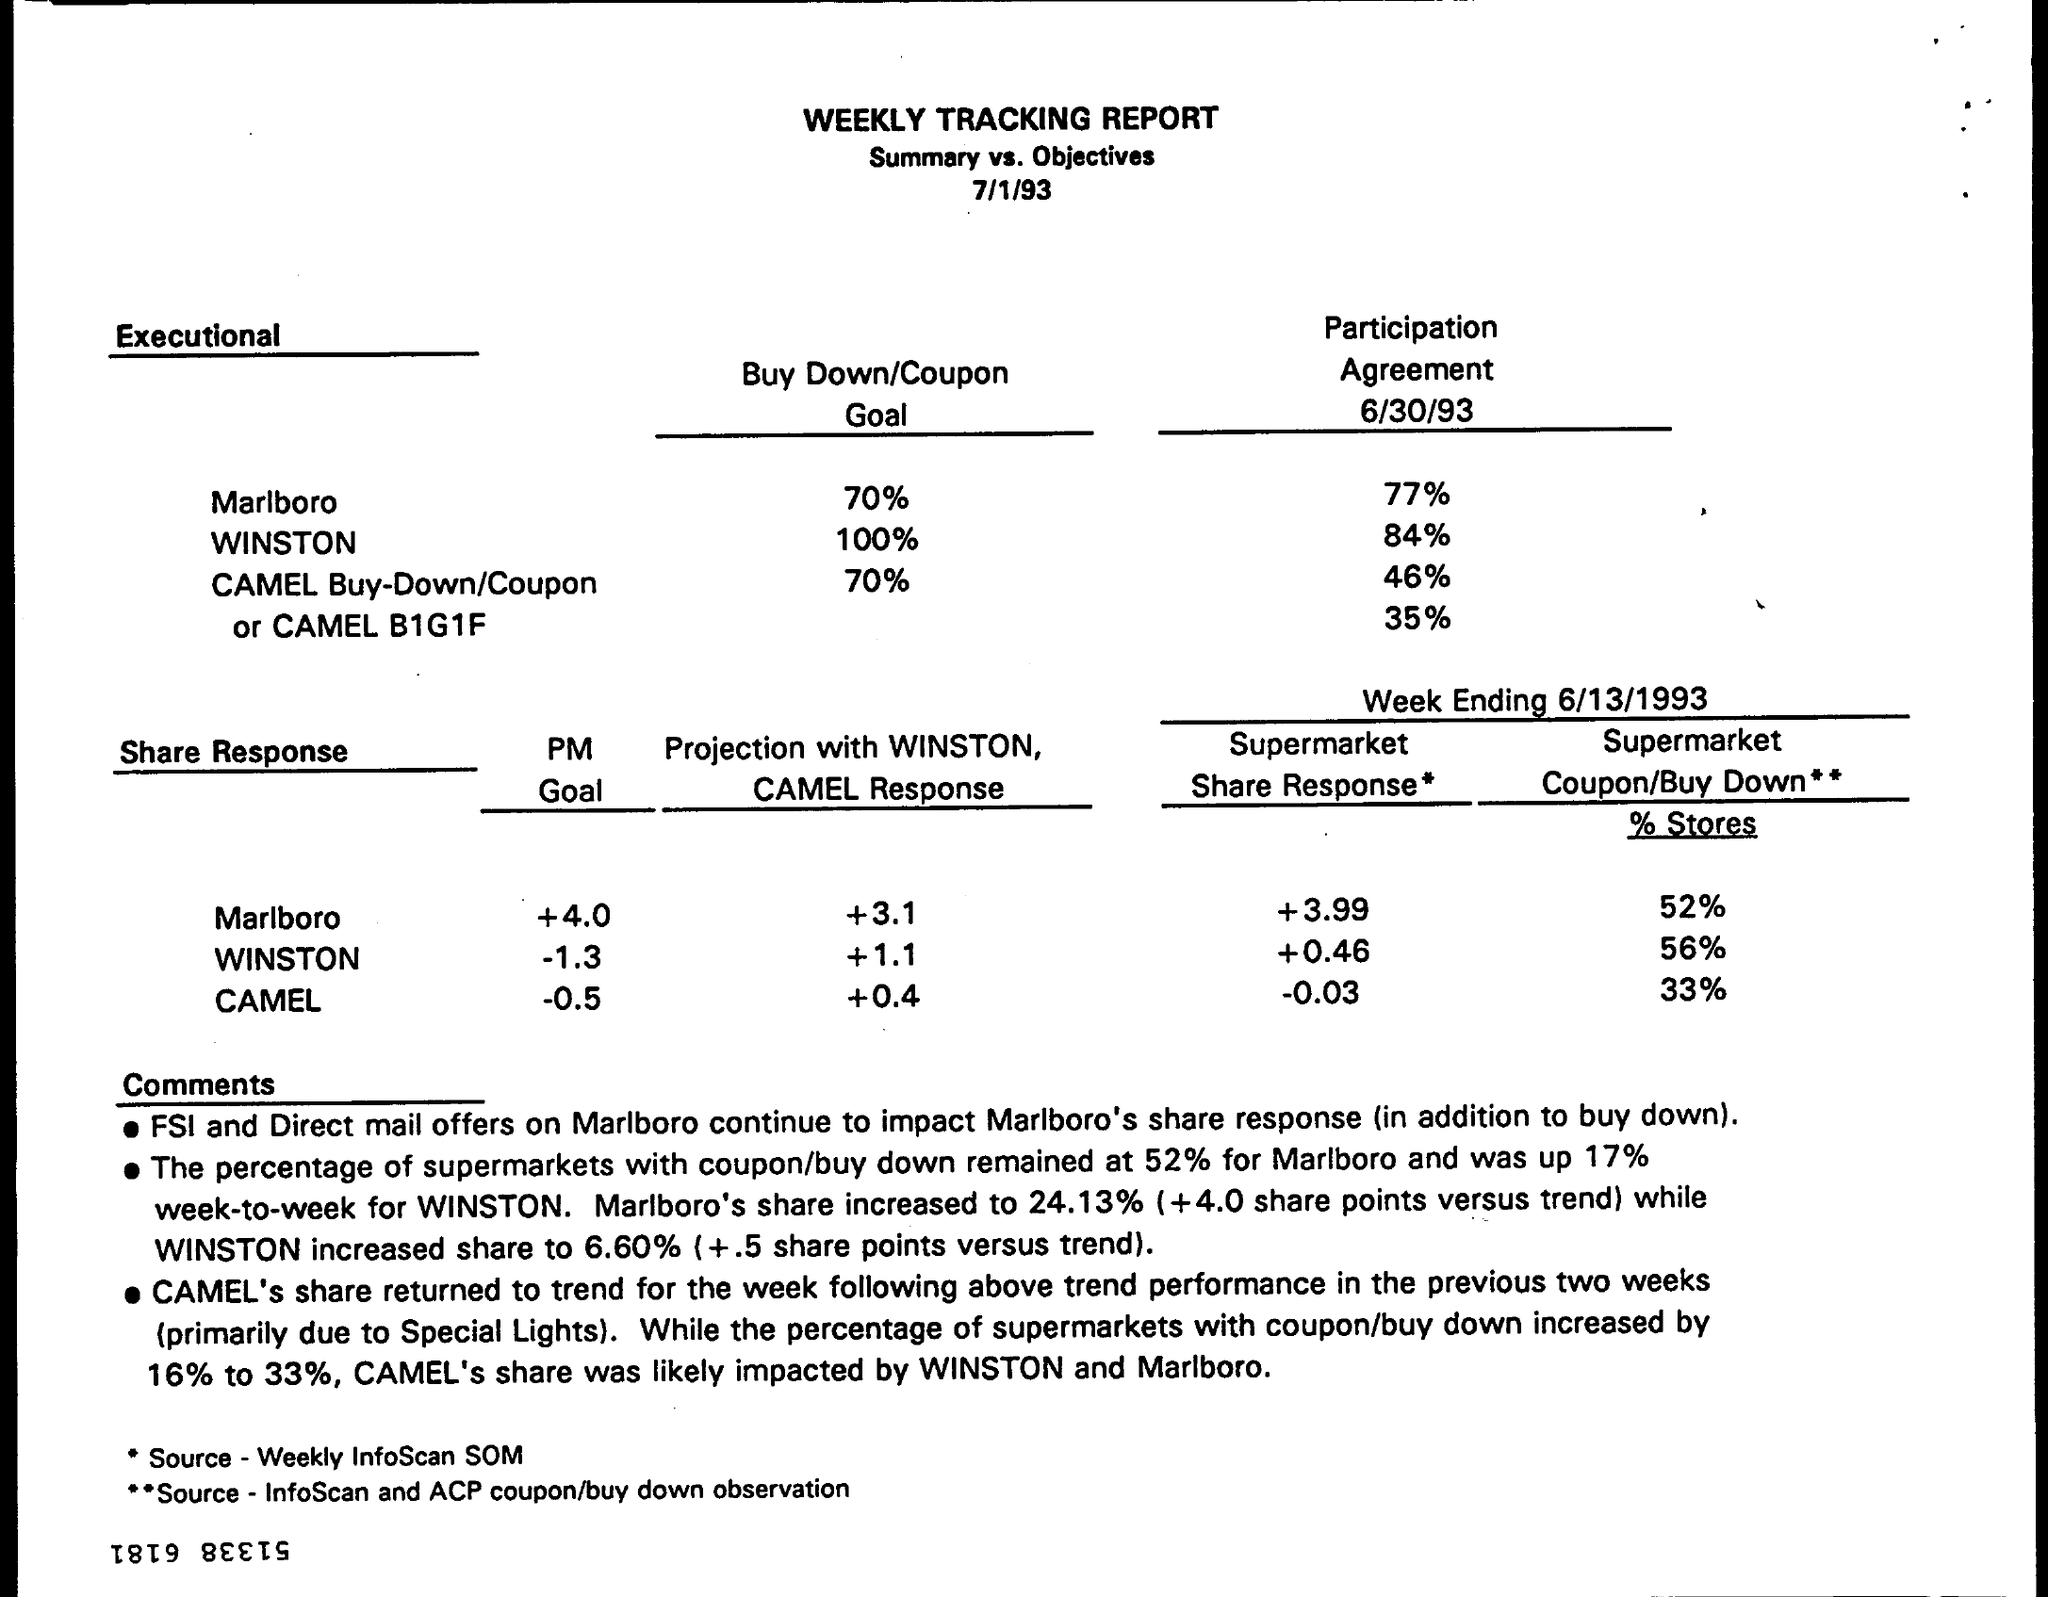What is the PM Goal for Marlboro? The PM Goal (Philip Morris Goal) for Marlboro as listed in the weekly tracking report dated 7/1/93 was to achieve a 4.0 share response, which refers to increasing Marlboro's market share by 4.0 percentage points. However, without additional context or knowing specific business metrics, it's unclear what these share points represent. 